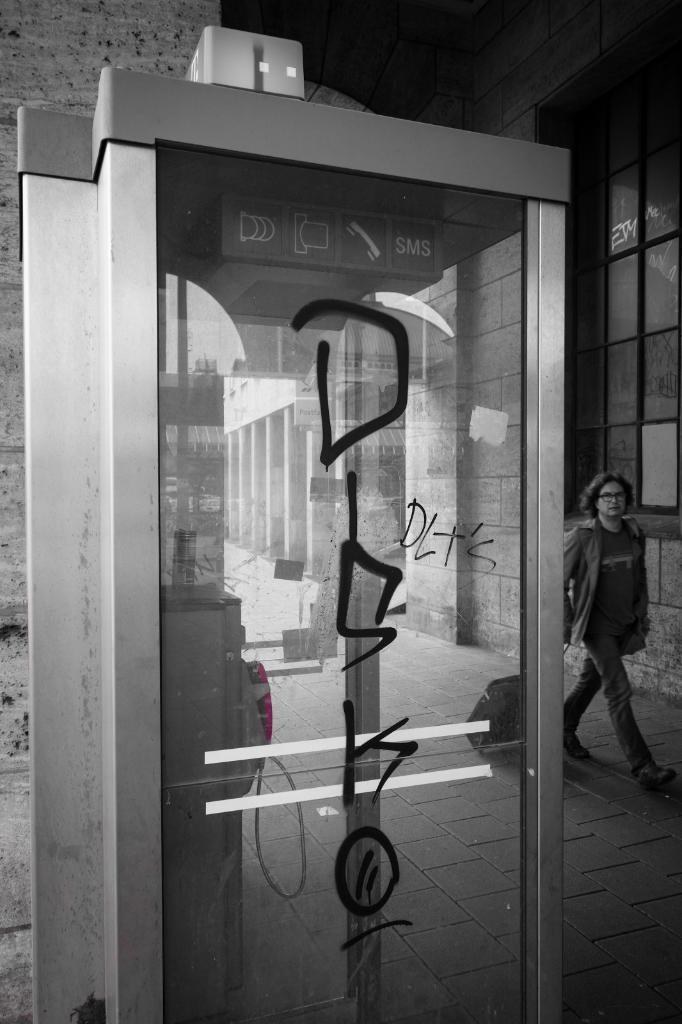In one or two sentences, can you explain what this image depicts? In the picture I can see a person is walking on the ground and holding a bag. Here I can see a glass door, a building and some other objects. This picture is black and white in color. 